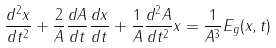Convert formula to latex. <formula><loc_0><loc_0><loc_500><loc_500>\frac { d ^ { 2 } x } { d t ^ { 2 } } + \frac { 2 } { A } \frac { d A } { d t } \frac { d x } { d t } + \frac { 1 } { A } \frac { d ^ { 2 } A } { d t ^ { 2 } } x = \frac { 1 } { A ^ { 3 } } E _ { g } ( x , t )</formula> 